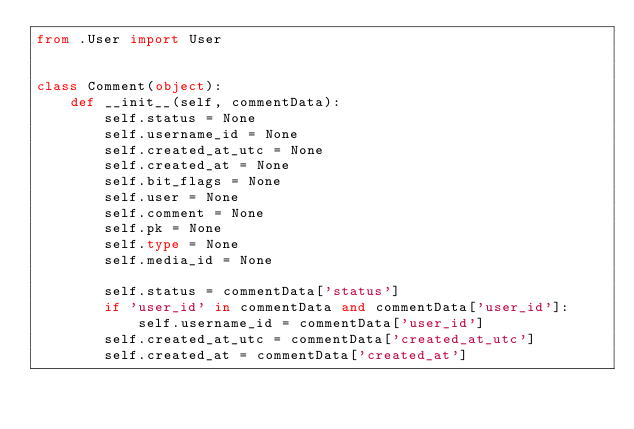<code> <loc_0><loc_0><loc_500><loc_500><_Python_>from .User import User


class Comment(object):
    def __init__(self, commentData):
        self.status = None
        self.username_id = None
        self.created_at_utc = None
        self.created_at = None
        self.bit_flags = None
        self.user = None
        self.comment = None
        self.pk = None
        self.type = None
        self.media_id = None

        self.status = commentData['status']
        if 'user_id' in commentData and commentData['user_id']:
            self.username_id = commentData['user_id']
        self.created_at_utc = commentData['created_at_utc']
        self.created_at = commentData['created_at']</code> 